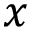Convert formula to latex. <formula><loc_0><loc_0><loc_500><loc_500>x</formula> 